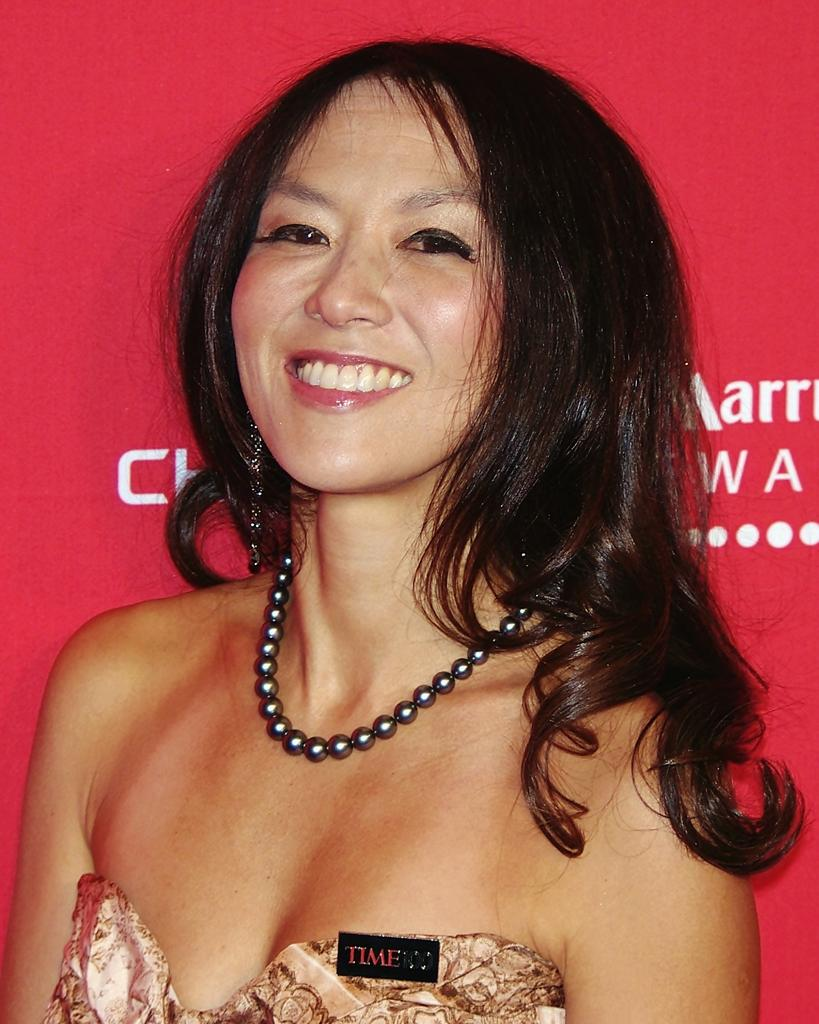Who or what is the main subject in the image? There is a person in the image. What is located behind the person? There is a banner with text behind the person. How many ducks are visible in the image? There are no ducks present in the image. What type of pickle is being held by the person in the image? There is no pickle visible in the image, and the person is not holding anything. 